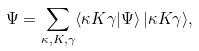Convert formula to latex. <formula><loc_0><loc_0><loc_500><loc_500>\Psi = \sum _ { \kappa , K , \gamma } \langle \kappa K \gamma | \Psi \rangle \, | \kappa K \gamma \rangle ,</formula> 